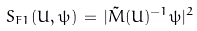<formula> <loc_0><loc_0><loc_500><loc_500>S _ { F 1 } ( U , \psi ) \, = \, | \tilde { M } ( U ) ^ { - 1 } \psi | ^ { 2 }</formula> 